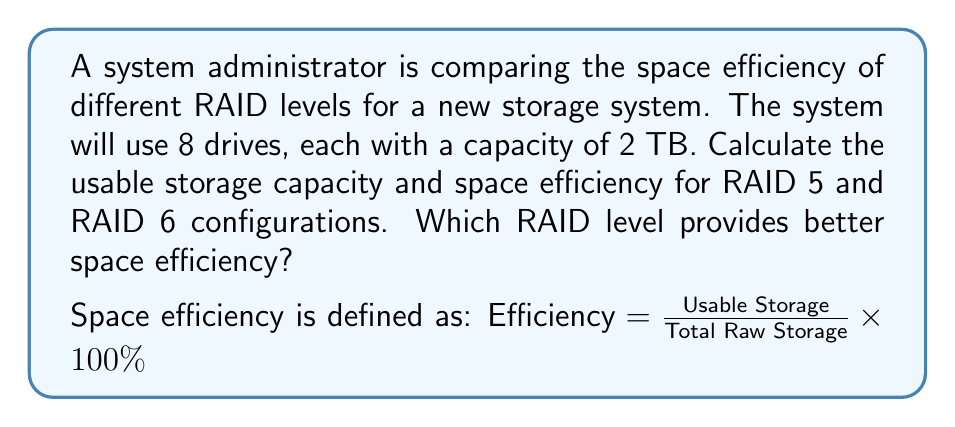Provide a solution to this math problem. To solve this problem, we need to calculate the usable storage and space efficiency for both RAID 5 and RAID 6 configurations:

1. Calculate total raw storage:
   Total raw storage = Number of drives × Capacity per drive
   $8 \times 2 \text{ TB} = 16 \text{ TB}$

2. RAID 5 calculation:
   - RAID 5 uses one drive for parity, so usable storage is (n-1) drives
   - Usable storage = $(8-1) \times 2 \text{ TB} = 14 \text{ TB}$
   - Efficiency = $\frac{14 \text{ TB}}{16 \text{ TB}} \times 100\% = 87.5\%$

3. RAID 6 calculation:
   - RAID 6 uses two drives for parity, so usable storage is (n-2) drives
   - Usable storage = $(8-2) \times 2 \text{ TB} = 12 \text{ TB}$
   - Efficiency = $\frac{12 \text{ TB}}{16 \text{ TB}} \times 100\% = 75\%$

4. Compare efficiencies:
   RAID 5: 87.5%
   RAID 6: 75%

RAID 5 provides better space efficiency in this case.
Answer: RAID 5 provides better space efficiency with 87.5% compared to RAID 6 with 75%. 